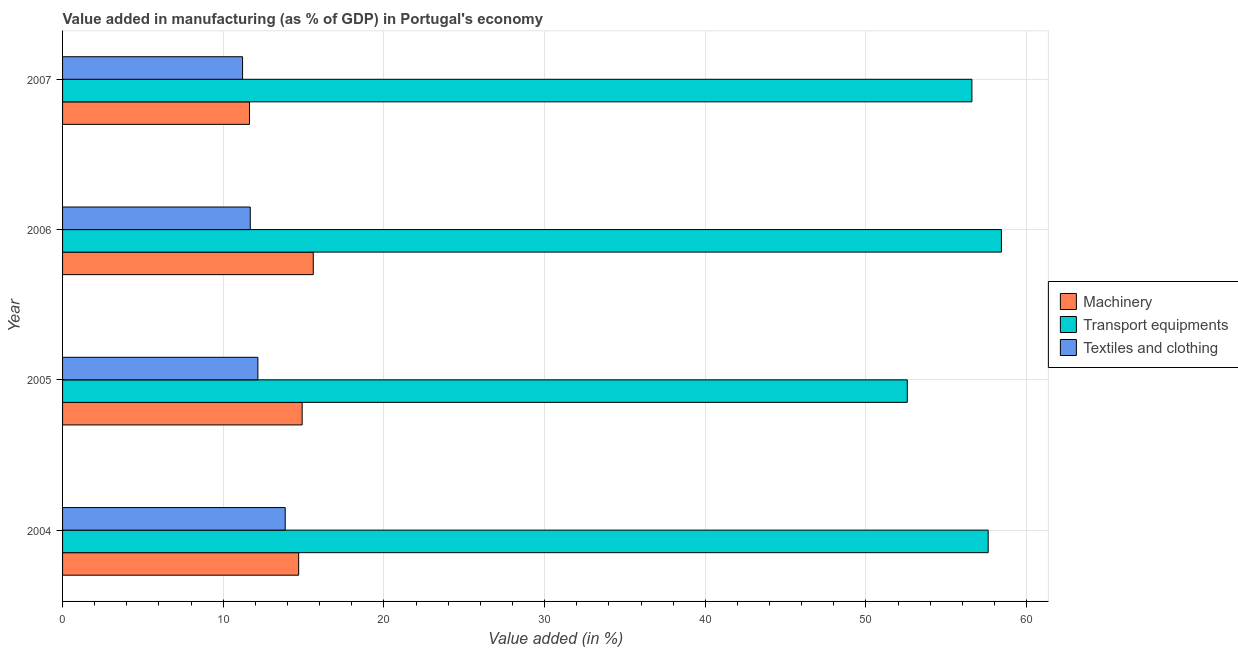Are the number of bars per tick equal to the number of legend labels?
Give a very brief answer. Yes. Are the number of bars on each tick of the Y-axis equal?
Your answer should be very brief. Yes. How many bars are there on the 2nd tick from the top?
Offer a terse response. 3. How many bars are there on the 2nd tick from the bottom?
Provide a succinct answer. 3. What is the label of the 4th group of bars from the top?
Offer a terse response. 2004. In how many cases, is the number of bars for a given year not equal to the number of legend labels?
Offer a very short reply. 0. What is the value added in manufacturing textile and clothing in 2007?
Offer a very short reply. 11.2. Across all years, what is the maximum value added in manufacturing machinery?
Make the answer very short. 15.6. Across all years, what is the minimum value added in manufacturing machinery?
Provide a short and direct response. 11.63. In which year was the value added in manufacturing transport equipments maximum?
Offer a terse response. 2006. What is the total value added in manufacturing machinery in the graph?
Keep it short and to the point. 56.84. What is the difference between the value added in manufacturing transport equipments in 2004 and that in 2005?
Offer a terse response. 5.03. What is the difference between the value added in manufacturing machinery in 2004 and the value added in manufacturing transport equipments in 2007?
Offer a very short reply. -41.9. What is the average value added in manufacturing transport equipments per year?
Provide a succinct answer. 56.3. In the year 2007, what is the difference between the value added in manufacturing transport equipments and value added in manufacturing machinery?
Offer a terse response. 44.96. What is the ratio of the value added in manufacturing textile and clothing in 2004 to that in 2005?
Your answer should be very brief. 1.14. What is the difference between the highest and the second highest value added in manufacturing transport equipments?
Give a very brief answer. 0.82. What is the difference between the highest and the lowest value added in manufacturing textile and clothing?
Your answer should be compact. 2.65. What does the 2nd bar from the top in 2007 represents?
Your answer should be very brief. Transport equipments. What does the 1st bar from the bottom in 2006 represents?
Offer a very short reply. Machinery. How many bars are there?
Offer a terse response. 12. Are all the bars in the graph horizontal?
Provide a short and direct response. Yes. How many years are there in the graph?
Give a very brief answer. 4. What is the difference between two consecutive major ticks on the X-axis?
Offer a terse response. 10. Does the graph contain any zero values?
Ensure brevity in your answer.  No. How are the legend labels stacked?
Your answer should be very brief. Vertical. What is the title of the graph?
Offer a terse response. Value added in manufacturing (as % of GDP) in Portugal's economy. What is the label or title of the X-axis?
Provide a succinct answer. Value added (in %). What is the label or title of the Y-axis?
Give a very brief answer. Year. What is the Value added (in %) in Machinery in 2004?
Provide a succinct answer. 14.69. What is the Value added (in %) of Transport equipments in 2004?
Make the answer very short. 57.6. What is the Value added (in %) of Textiles and clothing in 2004?
Keep it short and to the point. 13.86. What is the Value added (in %) in Machinery in 2005?
Provide a short and direct response. 14.91. What is the Value added (in %) in Transport equipments in 2005?
Provide a short and direct response. 52.57. What is the Value added (in %) in Textiles and clothing in 2005?
Your response must be concise. 12.16. What is the Value added (in %) in Machinery in 2006?
Your answer should be compact. 15.6. What is the Value added (in %) in Transport equipments in 2006?
Give a very brief answer. 58.43. What is the Value added (in %) of Textiles and clothing in 2006?
Your answer should be very brief. 11.68. What is the Value added (in %) in Machinery in 2007?
Provide a succinct answer. 11.63. What is the Value added (in %) in Transport equipments in 2007?
Keep it short and to the point. 56.59. What is the Value added (in %) in Textiles and clothing in 2007?
Provide a succinct answer. 11.2. Across all years, what is the maximum Value added (in %) in Machinery?
Your answer should be very brief. 15.6. Across all years, what is the maximum Value added (in %) of Transport equipments?
Offer a very short reply. 58.43. Across all years, what is the maximum Value added (in %) in Textiles and clothing?
Your answer should be very brief. 13.86. Across all years, what is the minimum Value added (in %) in Machinery?
Your answer should be very brief. 11.63. Across all years, what is the minimum Value added (in %) in Transport equipments?
Provide a short and direct response. 52.57. Across all years, what is the minimum Value added (in %) of Textiles and clothing?
Offer a terse response. 11.2. What is the total Value added (in %) of Machinery in the graph?
Provide a succinct answer. 56.84. What is the total Value added (in %) of Transport equipments in the graph?
Offer a very short reply. 225.2. What is the total Value added (in %) in Textiles and clothing in the graph?
Provide a succinct answer. 48.9. What is the difference between the Value added (in %) of Machinery in 2004 and that in 2005?
Make the answer very short. -0.22. What is the difference between the Value added (in %) of Transport equipments in 2004 and that in 2005?
Make the answer very short. 5.03. What is the difference between the Value added (in %) of Textiles and clothing in 2004 and that in 2005?
Your response must be concise. 1.7. What is the difference between the Value added (in %) of Machinery in 2004 and that in 2006?
Ensure brevity in your answer.  -0.91. What is the difference between the Value added (in %) of Transport equipments in 2004 and that in 2006?
Provide a succinct answer. -0.83. What is the difference between the Value added (in %) in Textiles and clothing in 2004 and that in 2006?
Keep it short and to the point. 2.17. What is the difference between the Value added (in %) of Machinery in 2004 and that in 2007?
Provide a short and direct response. 3.06. What is the difference between the Value added (in %) in Transport equipments in 2004 and that in 2007?
Your response must be concise. 1.01. What is the difference between the Value added (in %) of Textiles and clothing in 2004 and that in 2007?
Your answer should be very brief. 2.65. What is the difference between the Value added (in %) of Machinery in 2005 and that in 2006?
Offer a very short reply. -0.69. What is the difference between the Value added (in %) in Transport equipments in 2005 and that in 2006?
Ensure brevity in your answer.  -5.86. What is the difference between the Value added (in %) of Textiles and clothing in 2005 and that in 2006?
Your answer should be very brief. 0.47. What is the difference between the Value added (in %) in Machinery in 2005 and that in 2007?
Offer a terse response. 3.28. What is the difference between the Value added (in %) in Transport equipments in 2005 and that in 2007?
Offer a terse response. -4.02. What is the difference between the Value added (in %) in Textiles and clothing in 2005 and that in 2007?
Your answer should be very brief. 0.95. What is the difference between the Value added (in %) in Machinery in 2006 and that in 2007?
Provide a short and direct response. 3.97. What is the difference between the Value added (in %) in Transport equipments in 2006 and that in 2007?
Ensure brevity in your answer.  1.84. What is the difference between the Value added (in %) in Textiles and clothing in 2006 and that in 2007?
Offer a very short reply. 0.48. What is the difference between the Value added (in %) of Machinery in 2004 and the Value added (in %) of Transport equipments in 2005?
Your answer should be very brief. -37.88. What is the difference between the Value added (in %) in Machinery in 2004 and the Value added (in %) in Textiles and clothing in 2005?
Provide a succinct answer. 2.54. What is the difference between the Value added (in %) of Transport equipments in 2004 and the Value added (in %) of Textiles and clothing in 2005?
Your answer should be compact. 45.45. What is the difference between the Value added (in %) in Machinery in 2004 and the Value added (in %) in Transport equipments in 2006?
Offer a very short reply. -43.74. What is the difference between the Value added (in %) of Machinery in 2004 and the Value added (in %) of Textiles and clothing in 2006?
Keep it short and to the point. 3.01. What is the difference between the Value added (in %) in Transport equipments in 2004 and the Value added (in %) in Textiles and clothing in 2006?
Make the answer very short. 45.92. What is the difference between the Value added (in %) of Machinery in 2004 and the Value added (in %) of Transport equipments in 2007?
Give a very brief answer. -41.9. What is the difference between the Value added (in %) of Machinery in 2004 and the Value added (in %) of Textiles and clothing in 2007?
Your response must be concise. 3.49. What is the difference between the Value added (in %) in Transport equipments in 2004 and the Value added (in %) in Textiles and clothing in 2007?
Provide a short and direct response. 46.4. What is the difference between the Value added (in %) in Machinery in 2005 and the Value added (in %) in Transport equipments in 2006?
Your response must be concise. -43.52. What is the difference between the Value added (in %) in Machinery in 2005 and the Value added (in %) in Textiles and clothing in 2006?
Provide a succinct answer. 3.23. What is the difference between the Value added (in %) of Transport equipments in 2005 and the Value added (in %) of Textiles and clothing in 2006?
Your answer should be very brief. 40.89. What is the difference between the Value added (in %) of Machinery in 2005 and the Value added (in %) of Transport equipments in 2007?
Keep it short and to the point. -41.68. What is the difference between the Value added (in %) in Machinery in 2005 and the Value added (in %) in Textiles and clothing in 2007?
Provide a short and direct response. 3.71. What is the difference between the Value added (in %) in Transport equipments in 2005 and the Value added (in %) in Textiles and clothing in 2007?
Offer a terse response. 41.37. What is the difference between the Value added (in %) in Machinery in 2006 and the Value added (in %) in Transport equipments in 2007?
Your answer should be very brief. -40.99. What is the difference between the Value added (in %) in Machinery in 2006 and the Value added (in %) in Textiles and clothing in 2007?
Ensure brevity in your answer.  4.4. What is the difference between the Value added (in %) in Transport equipments in 2006 and the Value added (in %) in Textiles and clothing in 2007?
Give a very brief answer. 47.23. What is the average Value added (in %) of Machinery per year?
Ensure brevity in your answer.  14.21. What is the average Value added (in %) of Transport equipments per year?
Your answer should be compact. 56.3. What is the average Value added (in %) in Textiles and clothing per year?
Your response must be concise. 12.22. In the year 2004, what is the difference between the Value added (in %) of Machinery and Value added (in %) of Transport equipments?
Offer a very short reply. -42.91. In the year 2004, what is the difference between the Value added (in %) of Machinery and Value added (in %) of Textiles and clothing?
Your answer should be very brief. 0.84. In the year 2004, what is the difference between the Value added (in %) of Transport equipments and Value added (in %) of Textiles and clothing?
Your answer should be compact. 43.75. In the year 2005, what is the difference between the Value added (in %) in Machinery and Value added (in %) in Transport equipments?
Provide a short and direct response. -37.66. In the year 2005, what is the difference between the Value added (in %) in Machinery and Value added (in %) in Textiles and clothing?
Provide a short and direct response. 2.76. In the year 2005, what is the difference between the Value added (in %) of Transport equipments and Value added (in %) of Textiles and clothing?
Make the answer very short. 40.42. In the year 2006, what is the difference between the Value added (in %) in Machinery and Value added (in %) in Transport equipments?
Your answer should be very brief. -42.83. In the year 2006, what is the difference between the Value added (in %) in Machinery and Value added (in %) in Textiles and clothing?
Keep it short and to the point. 3.92. In the year 2006, what is the difference between the Value added (in %) of Transport equipments and Value added (in %) of Textiles and clothing?
Your answer should be very brief. 46.75. In the year 2007, what is the difference between the Value added (in %) of Machinery and Value added (in %) of Transport equipments?
Your response must be concise. -44.96. In the year 2007, what is the difference between the Value added (in %) of Machinery and Value added (in %) of Textiles and clothing?
Offer a very short reply. 0.43. In the year 2007, what is the difference between the Value added (in %) in Transport equipments and Value added (in %) in Textiles and clothing?
Your answer should be compact. 45.39. What is the ratio of the Value added (in %) of Machinery in 2004 to that in 2005?
Your answer should be very brief. 0.99. What is the ratio of the Value added (in %) of Transport equipments in 2004 to that in 2005?
Give a very brief answer. 1.1. What is the ratio of the Value added (in %) in Textiles and clothing in 2004 to that in 2005?
Give a very brief answer. 1.14. What is the ratio of the Value added (in %) of Machinery in 2004 to that in 2006?
Make the answer very short. 0.94. What is the ratio of the Value added (in %) of Transport equipments in 2004 to that in 2006?
Provide a short and direct response. 0.99. What is the ratio of the Value added (in %) of Textiles and clothing in 2004 to that in 2006?
Keep it short and to the point. 1.19. What is the ratio of the Value added (in %) of Machinery in 2004 to that in 2007?
Your answer should be compact. 1.26. What is the ratio of the Value added (in %) of Transport equipments in 2004 to that in 2007?
Offer a terse response. 1.02. What is the ratio of the Value added (in %) of Textiles and clothing in 2004 to that in 2007?
Ensure brevity in your answer.  1.24. What is the ratio of the Value added (in %) of Machinery in 2005 to that in 2006?
Your answer should be compact. 0.96. What is the ratio of the Value added (in %) in Transport equipments in 2005 to that in 2006?
Your answer should be compact. 0.9. What is the ratio of the Value added (in %) in Textiles and clothing in 2005 to that in 2006?
Offer a terse response. 1.04. What is the ratio of the Value added (in %) of Machinery in 2005 to that in 2007?
Your answer should be very brief. 1.28. What is the ratio of the Value added (in %) of Transport equipments in 2005 to that in 2007?
Keep it short and to the point. 0.93. What is the ratio of the Value added (in %) of Textiles and clothing in 2005 to that in 2007?
Make the answer very short. 1.08. What is the ratio of the Value added (in %) in Machinery in 2006 to that in 2007?
Provide a succinct answer. 1.34. What is the ratio of the Value added (in %) in Transport equipments in 2006 to that in 2007?
Provide a short and direct response. 1.03. What is the ratio of the Value added (in %) in Textiles and clothing in 2006 to that in 2007?
Provide a short and direct response. 1.04. What is the difference between the highest and the second highest Value added (in %) in Machinery?
Make the answer very short. 0.69. What is the difference between the highest and the second highest Value added (in %) in Transport equipments?
Ensure brevity in your answer.  0.83. What is the difference between the highest and the second highest Value added (in %) of Textiles and clothing?
Give a very brief answer. 1.7. What is the difference between the highest and the lowest Value added (in %) of Machinery?
Offer a very short reply. 3.97. What is the difference between the highest and the lowest Value added (in %) of Transport equipments?
Your response must be concise. 5.86. What is the difference between the highest and the lowest Value added (in %) of Textiles and clothing?
Give a very brief answer. 2.65. 